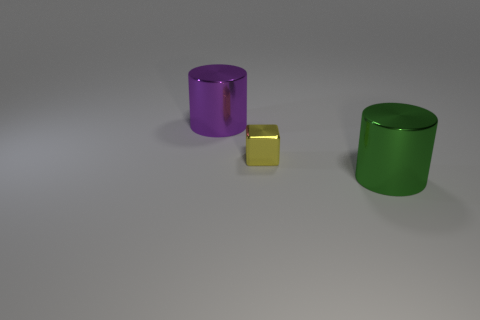Subtract 1 cylinders. How many cylinders are left? 1 Subtract all blocks. How many objects are left? 2 Subtract all purple cylinders. How many cylinders are left? 1 Add 3 small yellow cubes. How many objects exist? 6 Add 1 shiny cylinders. How many shiny cylinders exist? 3 Subtract 1 purple cylinders. How many objects are left? 2 Subtract all yellow cylinders. Subtract all brown blocks. How many cylinders are left? 2 Subtract all yellow spheres. How many purple cylinders are left? 1 Subtract all metallic things. Subtract all small red cylinders. How many objects are left? 0 Add 3 metal things. How many metal things are left? 6 